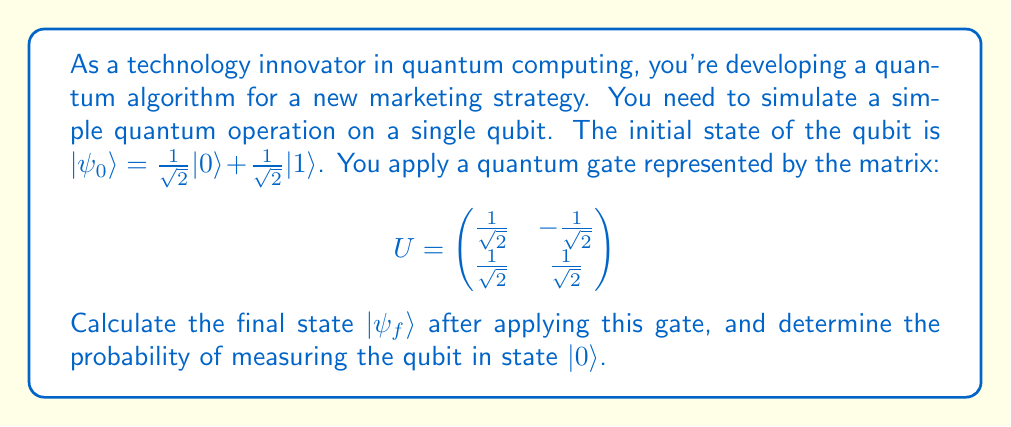Give your solution to this math problem. To solve this problem, we'll follow these steps:

1) First, let's represent the initial state as a column vector:

   $$|\psi_0\rangle = \begin{pmatrix}
   \frac{1}{\sqrt{2}} \\
   \frac{1}{\sqrt{2}}
   \end{pmatrix}$$

2) To find the final state, we multiply the gate matrix $U$ by the initial state vector:

   $$|\psi_f\rangle = U|\psi_0\rangle = \begin{pmatrix}
   \frac{1}{\sqrt{2}} & -\frac{1}{\sqrt{2}} \\
   \frac{1}{\sqrt{2}} & \frac{1}{\sqrt{2}}
   \end{pmatrix} \begin{pmatrix}
   \frac{1}{\sqrt{2}} \\
   \frac{1}{\sqrt{2}}
   \end{pmatrix}$$

3) Let's perform the matrix multiplication:

   $$|\psi_f\rangle = \begin{pmatrix}
   \frac{1}{\sqrt{2}} \cdot \frac{1}{\sqrt{2}} + (-\frac{1}{\sqrt{2}}) \cdot \frac{1}{\sqrt{2}} \\
   \frac{1}{\sqrt{2}} \cdot \frac{1}{\sqrt{2}} + \frac{1}{\sqrt{2}} \cdot \frac{1}{\sqrt{2}}
   \end{pmatrix} = \begin{pmatrix}
   \frac{1}{2} - \frac{1}{2} \\
   \frac{1}{2} + \frac{1}{2}
   \end{pmatrix} = \begin{pmatrix}
   0 \\
   1
   \end{pmatrix}$$

4) Therefore, the final state is $|\psi_f\rangle = |1\rangle$.

5) To find the probability of measuring the qubit in state $|0\rangle$, we need to calculate the square of the magnitude of the amplitude for $|0\rangle$:

   $P(|0\rangle) = |⟨0|\psi_f⟩|^2 = |0|^2 = 0$

This means there is a 0% chance of measuring the qubit in state $|0\rangle$.
Answer: The final state is $|\psi_f\rangle = |1\rangle$, and the probability of measuring the qubit in state $|0\rangle$ is 0. 